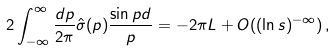Convert formula to latex. <formula><loc_0><loc_0><loc_500><loc_500>2 \int _ { - \infty } ^ { \infty } \frac { d p } { 2 \pi } \hat { \sigma } ( p ) \frac { \sin p d } { p } = - 2 \pi L + O ( ( { \ln s } ) ^ { - \infty } ) \, ,</formula> 